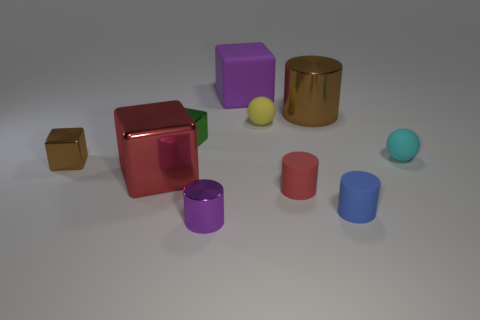Is the shape of the large purple thing the same as the small green thing?
Your answer should be very brief. Yes. How many tiny objects are either yellow metal balls or purple things?
Your answer should be very brief. 1. There is a red cylinder; are there any yellow matte objects on the left side of it?
Keep it short and to the point. Yes. Is the number of large purple rubber things that are in front of the tiny blue thing the same as the number of blue things?
Make the answer very short. No. There is another thing that is the same shape as the tiny yellow rubber thing; what size is it?
Provide a succinct answer. Small. Is the shape of the big red shiny thing the same as the tiny rubber thing that is behind the small cyan matte object?
Provide a short and direct response. No. There is a brown object that is to the right of the purple thing in front of the purple matte object; what is its size?
Provide a succinct answer. Large. Are there an equal number of blocks that are in front of the small yellow sphere and tiny purple things that are to the right of the tiny blue matte thing?
Give a very brief answer. No. The other tiny rubber object that is the same shape as the cyan rubber thing is what color?
Make the answer very short. Yellow. What number of small balls are the same color as the large shiny cylinder?
Provide a succinct answer. 0. 